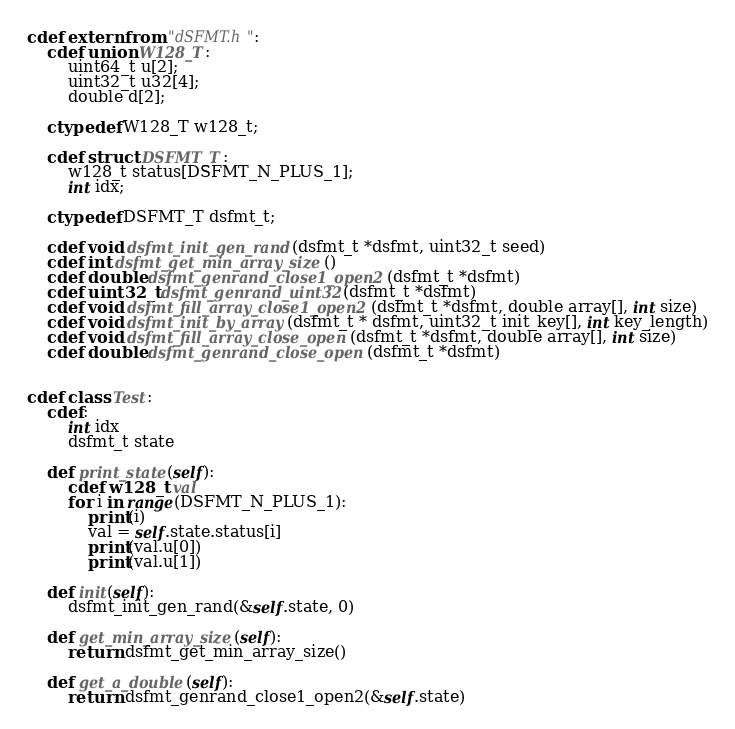<code> <loc_0><loc_0><loc_500><loc_500><_Cython_>
cdef extern from "dSFMT.h":
    cdef union W128_T:
        uint64_t u[2];
        uint32_t u32[4];
        double d[2];

    ctypedef W128_T w128_t;

    cdef struct DSFMT_T:
        w128_t status[DSFMT_N_PLUS_1];
        int idx;

    ctypedef DSFMT_T dsfmt_t;

    cdef void dsfmt_init_gen_rand(dsfmt_t *dsfmt, uint32_t seed)
    cdef int dsfmt_get_min_array_size()
    cdef double dsfmt_genrand_close1_open2(dsfmt_t *dsfmt)
    cdef uint32_t dsfmt_genrand_uint32(dsfmt_t *dsfmt)
    cdef void dsfmt_fill_array_close1_open2(dsfmt_t *dsfmt, double array[], int size)
    cdef void dsfmt_init_by_array(dsfmt_t * dsfmt, uint32_t init_key[], int key_length)
    cdef void dsfmt_fill_array_close_open(dsfmt_t *dsfmt, double array[], int size)
    cdef double dsfmt_genrand_close_open(dsfmt_t *dsfmt)


cdef class Test:
    cdef:
        int idx
        dsfmt_t state

    def print_state(self):
        cdef w128_t val
        for i in range(DSFMT_N_PLUS_1):
            print(i)
            val = self.state.status[i]
            print(val.u[0])
            print(val.u[1])

    def init(self):
        dsfmt_init_gen_rand(&self.state, 0)

    def get_min_array_size(self):
        return dsfmt_get_min_array_size()

    def get_a_double(self):
        return dsfmt_genrand_close1_open2(&self.state)

</code> 